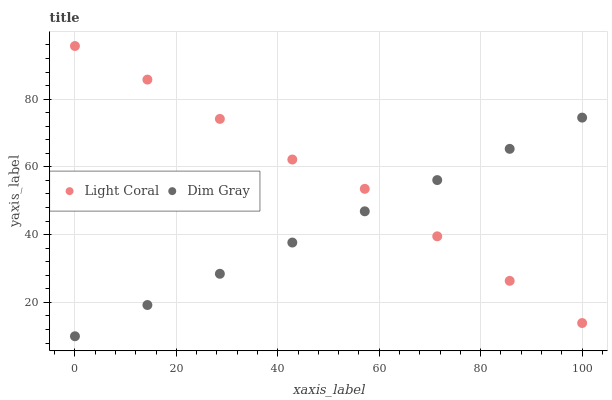Does Dim Gray have the minimum area under the curve?
Answer yes or no. Yes. Does Light Coral have the maximum area under the curve?
Answer yes or no. Yes. Does Dim Gray have the maximum area under the curve?
Answer yes or no. No. Is Dim Gray the smoothest?
Answer yes or no. Yes. Is Light Coral the roughest?
Answer yes or no. Yes. Is Dim Gray the roughest?
Answer yes or no. No. Does Dim Gray have the lowest value?
Answer yes or no. Yes. Does Light Coral have the highest value?
Answer yes or no. Yes. Does Dim Gray have the highest value?
Answer yes or no. No. Does Dim Gray intersect Light Coral?
Answer yes or no. Yes. Is Dim Gray less than Light Coral?
Answer yes or no. No. Is Dim Gray greater than Light Coral?
Answer yes or no. No. 